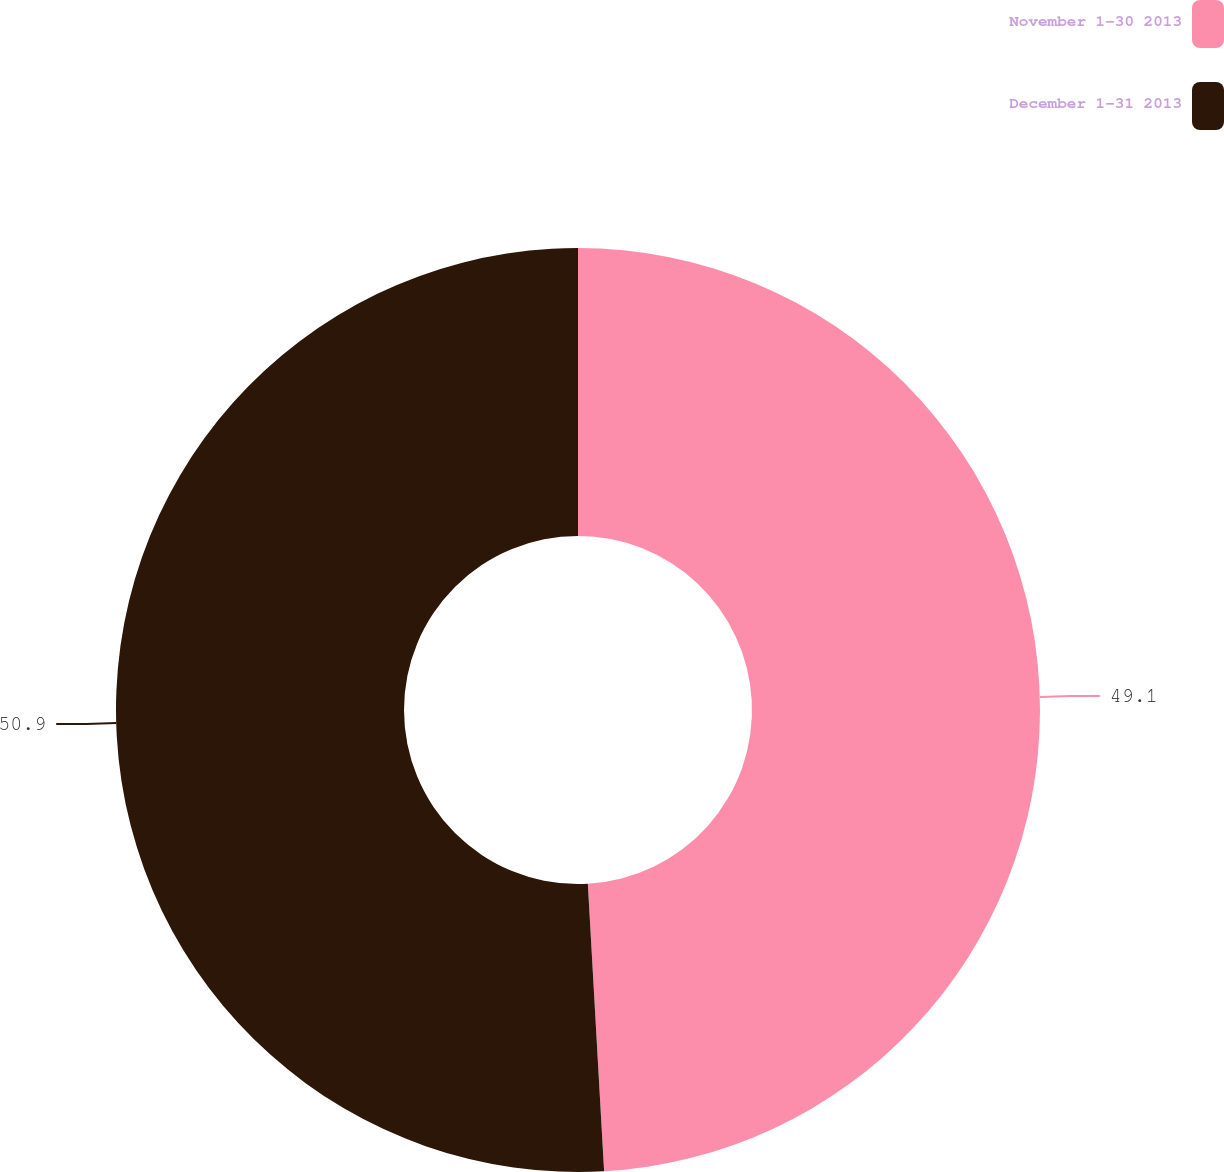<chart> <loc_0><loc_0><loc_500><loc_500><pie_chart><fcel>November 1-30 2013<fcel>December 1-31 2013<nl><fcel>49.1%<fcel>50.9%<nl></chart> 